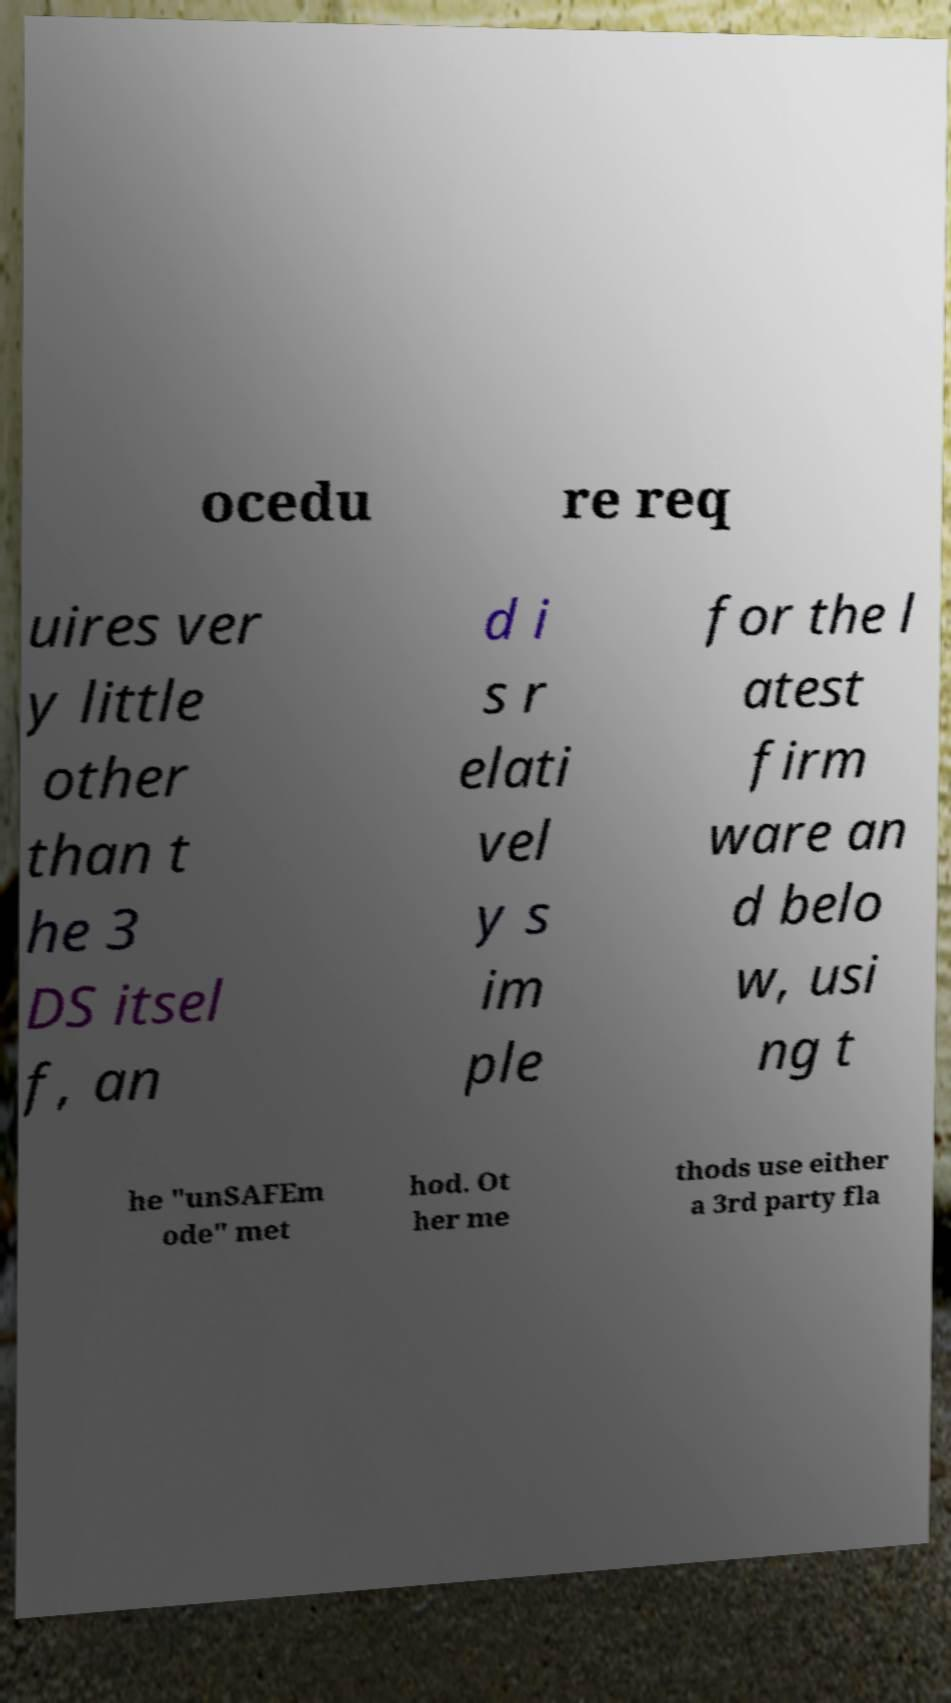Could you extract and type out the text from this image? ocedu re req uires ver y little other than t he 3 DS itsel f, an d i s r elati vel y s im ple for the l atest firm ware an d belo w, usi ng t he "unSAFEm ode" met hod. Ot her me thods use either a 3rd party fla 